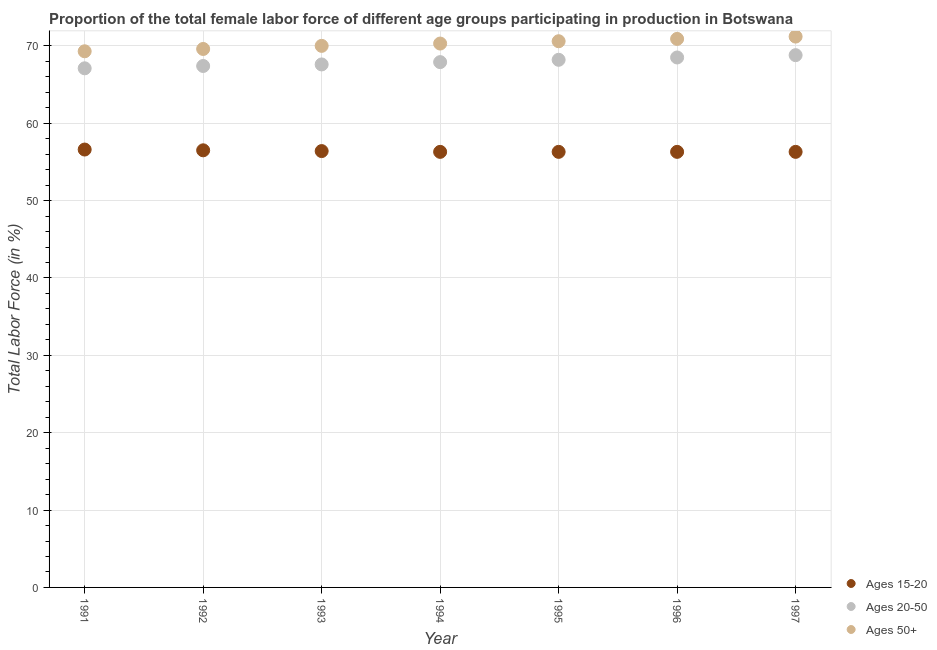Is the number of dotlines equal to the number of legend labels?
Keep it short and to the point. Yes. What is the percentage of female labor force within the age group 15-20 in 1993?
Your answer should be very brief. 56.4. Across all years, what is the maximum percentage of female labor force above age 50?
Offer a terse response. 71.2. Across all years, what is the minimum percentage of female labor force above age 50?
Ensure brevity in your answer.  69.3. In which year was the percentage of female labor force above age 50 minimum?
Keep it short and to the point. 1991. What is the total percentage of female labor force above age 50 in the graph?
Your answer should be compact. 491.9. What is the difference between the percentage of female labor force within the age group 20-50 in 1994 and that in 1997?
Make the answer very short. -0.9. What is the difference between the percentage of female labor force within the age group 15-20 in 1994 and the percentage of female labor force above age 50 in 1993?
Make the answer very short. -13.7. What is the average percentage of female labor force above age 50 per year?
Your response must be concise. 70.27. In the year 1996, what is the difference between the percentage of female labor force within the age group 15-20 and percentage of female labor force within the age group 20-50?
Provide a succinct answer. -12.2. In how many years, is the percentage of female labor force within the age group 20-50 greater than 18 %?
Give a very brief answer. 7. What is the ratio of the percentage of female labor force above age 50 in 1992 to that in 1996?
Your answer should be very brief. 0.98. Is the difference between the percentage of female labor force within the age group 15-20 in 1991 and 1997 greater than the difference between the percentage of female labor force within the age group 20-50 in 1991 and 1997?
Your response must be concise. Yes. What is the difference between the highest and the second highest percentage of female labor force above age 50?
Your response must be concise. 0.3. What is the difference between the highest and the lowest percentage of female labor force within the age group 20-50?
Provide a short and direct response. 1.7. Is the sum of the percentage of female labor force above age 50 in 1992 and 1993 greater than the maximum percentage of female labor force within the age group 15-20 across all years?
Offer a very short reply. Yes. Is it the case that in every year, the sum of the percentage of female labor force within the age group 15-20 and percentage of female labor force within the age group 20-50 is greater than the percentage of female labor force above age 50?
Provide a short and direct response. Yes. Does the percentage of female labor force within the age group 15-20 monotonically increase over the years?
Keep it short and to the point. No. How many years are there in the graph?
Ensure brevity in your answer.  7. Are the values on the major ticks of Y-axis written in scientific E-notation?
Make the answer very short. No. Does the graph contain grids?
Give a very brief answer. Yes. How many legend labels are there?
Offer a very short reply. 3. What is the title of the graph?
Give a very brief answer. Proportion of the total female labor force of different age groups participating in production in Botswana. What is the label or title of the X-axis?
Provide a succinct answer. Year. What is the label or title of the Y-axis?
Provide a short and direct response. Total Labor Force (in %). What is the Total Labor Force (in %) in Ages 15-20 in 1991?
Your answer should be compact. 56.6. What is the Total Labor Force (in %) of Ages 20-50 in 1991?
Keep it short and to the point. 67.1. What is the Total Labor Force (in %) in Ages 50+ in 1991?
Keep it short and to the point. 69.3. What is the Total Labor Force (in %) in Ages 15-20 in 1992?
Keep it short and to the point. 56.5. What is the Total Labor Force (in %) of Ages 20-50 in 1992?
Make the answer very short. 67.4. What is the Total Labor Force (in %) in Ages 50+ in 1992?
Offer a terse response. 69.6. What is the Total Labor Force (in %) in Ages 15-20 in 1993?
Make the answer very short. 56.4. What is the Total Labor Force (in %) in Ages 20-50 in 1993?
Offer a terse response. 67.6. What is the Total Labor Force (in %) in Ages 50+ in 1993?
Offer a very short reply. 70. What is the Total Labor Force (in %) of Ages 15-20 in 1994?
Your answer should be very brief. 56.3. What is the Total Labor Force (in %) in Ages 20-50 in 1994?
Offer a very short reply. 67.9. What is the Total Labor Force (in %) in Ages 50+ in 1994?
Ensure brevity in your answer.  70.3. What is the Total Labor Force (in %) of Ages 15-20 in 1995?
Give a very brief answer. 56.3. What is the Total Labor Force (in %) of Ages 20-50 in 1995?
Offer a very short reply. 68.2. What is the Total Labor Force (in %) in Ages 50+ in 1995?
Offer a very short reply. 70.6. What is the Total Labor Force (in %) in Ages 15-20 in 1996?
Ensure brevity in your answer.  56.3. What is the Total Labor Force (in %) of Ages 20-50 in 1996?
Ensure brevity in your answer.  68.5. What is the Total Labor Force (in %) of Ages 50+ in 1996?
Provide a succinct answer. 70.9. What is the Total Labor Force (in %) of Ages 15-20 in 1997?
Offer a very short reply. 56.3. What is the Total Labor Force (in %) in Ages 20-50 in 1997?
Keep it short and to the point. 68.8. What is the Total Labor Force (in %) of Ages 50+ in 1997?
Give a very brief answer. 71.2. Across all years, what is the maximum Total Labor Force (in %) in Ages 15-20?
Offer a very short reply. 56.6. Across all years, what is the maximum Total Labor Force (in %) of Ages 20-50?
Offer a very short reply. 68.8. Across all years, what is the maximum Total Labor Force (in %) in Ages 50+?
Ensure brevity in your answer.  71.2. Across all years, what is the minimum Total Labor Force (in %) of Ages 15-20?
Provide a short and direct response. 56.3. Across all years, what is the minimum Total Labor Force (in %) in Ages 20-50?
Give a very brief answer. 67.1. Across all years, what is the minimum Total Labor Force (in %) of Ages 50+?
Your response must be concise. 69.3. What is the total Total Labor Force (in %) of Ages 15-20 in the graph?
Ensure brevity in your answer.  394.7. What is the total Total Labor Force (in %) in Ages 20-50 in the graph?
Your response must be concise. 475.5. What is the total Total Labor Force (in %) of Ages 50+ in the graph?
Your answer should be compact. 491.9. What is the difference between the Total Labor Force (in %) in Ages 20-50 in 1991 and that in 1992?
Your answer should be compact. -0.3. What is the difference between the Total Labor Force (in %) of Ages 15-20 in 1991 and that in 1993?
Give a very brief answer. 0.2. What is the difference between the Total Labor Force (in %) of Ages 50+ in 1991 and that in 1993?
Ensure brevity in your answer.  -0.7. What is the difference between the Total Labor Force (in %) in Ages 15-20 in 1991 and that in 1994?
Keep it short and to the point. 0.3. What is the difference between the Total Labor Force (in %) in Ages 50+ in 1991 and that in 1994?
Provide a succinct answer. -1. What is the difference between the Total Labor Force (in %) in Ages 20-50 in 1991 and that in 1995?
Your response must be concise. -1.1. What is the difference between the Total Labor Force (in %) of Ages 50+ in 1991 and that in 1995?
Provide a succinct answer. -1.3. What is the difference between the Total Labor Force (in %) of Ages 50+ in 1991 and that in 1996?
Your response must be concise. -1.6. What is the difference between the Total Labor Force (in %) in Ages 15-20 in 1991 and that in 1997?
Your answer should be very brief. 0.3. What is the difference between the Total Labor Force (in %) in Ages 50+ in 1991 and that in 1997?
Your response must be concise. -1.9. What is the difference between the Total Labor Force (in %) of Ages 15-20 in 1992 and that in 1994?
Keep it short and to the point. 0.2. What is the difference between the Total Labor Force (in %) of Ages 15-20 in 1992 and that in 1995?
Your response must be concise. 0.2. What is the difference between the Total Labor Force (in %) of Ages 50+ in 1992 and that in 1995?
Your answer should be very brief. -1. What is the difference between the Total Labor Force (in %) in Ages 15-20 in 1992 and that in 1996?
Ensure brevity in your answer.  0.2. What is the difference between the Total Labor Force (in %) in Ages 50+ in 1992 and that in 1996?
Keep it short and to the point. -1.3. What is the difference between the Total Labor Force (in %) in Ages 15-20 in 1992 and that in 1997?
Your answer should be very brief. 0.2. What is the difference between the Total Labor Force (in %) in Ages 20-50 in 1992 and that in 1997?
Offer a terse response. -1.4. What is the difference between the Total Labor Force (in %) of Ages 15-20 in 1993 and that in 1997?
Keep it short and to the point. 0.1. What is the difference between the Total Labor Force (in %) in Ages 50+ in 1993 and that in 1997?
Provide a succinct answer. -1.2. What is the difference between the Total Labor Force (in %) in Ages 20-50 in 1994 and that in 1995?
Your answer should be compact. -0.3. What is the difference between the Total Labor Force (in %) in Ages 20-50 in 1994 and that in 1996?
Offer a very short reply. -0.6. What is the difference between the Total Labor Force (in %) of Ages 15-20 in 1994 and that in 1997?
Ensure brevity in your answer.  0. What is the difference between the Total Labor Force (in %) in Ages 20-50 in 1994 and that in 1997?
Provide a succinct answer. -0.9. What is the difference between the Total Labor Force (in %) in Ages 50+ in 1994 and that in 1997?
Offer a terse response. -0.9. What is the difference between the Total Labor Force (in %) in Ages 50+ in 1995 and that in 1996?
Make the answer very short. -0.3. What is the difference between the Total Labor Force (in %) of Ages 20-50 in 1995 and that in 1997?
Provide a succinct answer. -0.6. What is the difference between the Total Labor Force (in %) in Ages 15-20 in 1996 and that in 1997?
Ensure brevity in your answer.  0. What is the difference between the Total Labor Force (in %) in Ages 15-20 in 1991 and the Total Labor Force (in %) in Ages 20-50 in 1992?
Keep it short and to the point. -10.8. What is the difference between the Total Labor Force (in %) in Ages 15-20 in 1991 and the Total Labor Force (in %) in Ages 50+ in 1992?
Keep it short and to the point. -13. What is the difference between the Total Labor Force (in %) in Ages 15-20 in 1991 and the Total Labor Force (in %) in Ages 20-50 in 1993?
Make the answer very short. -11. What is the difference between the Total Labor Force (in %) of Ages 15-20 in 1991 and the Total Labor Force (in %) of Ages 50+ in 1993?
Give a very brief answer. -13.4. What is the difference between the Total Labor Force (in %) of Ages 15-20 in 1991 and the Total Labor Force (in %) of Ages 50+ in 1994?
Keep it short and to the point. -13.7. What is the difference between the Total Labor Force (in %) of Ages 15-20 in 1991 and the Total Labor Force (in %) of Ages 20-50 in 1995?
Offer a very short reply. -11.6. What is the difference between the Total Labor Force (in %) of Ages 15-20 in 1991 and the Total Labor Force (in %) of Ages 20-50 in 1996?
Offer a terse response. -11.9. What is the difference between the Total Labor Force (in %) of Ages 15-20 in 1991 and the Total Labor Force (in %) of Ages 50+ in 1996?
Keep it short and to the point. -14.3. What is the difference between the Total Labor Force (in %) of Ages 15-20 in 1991 and the Total Labor Force (in %) of Ages 50+ in 1997?
Make the answer very short. -14.6. What is the difference between the Total Labor Force (in %) in Ages 20-50 in 1991 and the Total Labor Force (in %) in Ages 50+ in 1997?
Your response must be concise. -4.1. What is the difference between the Total Labor Force (in %) in Ages 15-20 in 1992 and the Total Labor Force (in %) in Ages 20-50 in 1993?
Your answer should be compact. -11.1. What is the difference between the Total Labor Force (in %) of Ages 15-20 in 1992 and the Total Labor Force (in %) of Ages 50+ in 1993?
Give a very brief answer. -13.5. What is the difference between the Total Labor Force (in %) in Ages 15-20 in 1992 and the Total Labor Force (in %) in Ages 50+ in 1995?
Your response must be concise. -14.1. What is the difference between the Total Labor Force (in %) of Ages 15-20 in 1992 and the Total Labor Force (in %) of Ages 50+ in 1996?
Keep it short and to the point. -14.4. What is the difference between the Total Labor Force (in %) in Ages 15-20 in 1992 and the Total Labor Force (in %) in Ages 50+ in 1997?
Offer a terse response. -14.7. What is the difference between the Total Labor Force (in %) in Ages 20-50 in 1992 and the Total Labor Force (in %) in Ages 50+ in 1997?
Your answer should be compact. -3.8. What is the difference between the Total Labor Force (in %) of Ages 20-50 in 1993 and the Total Labor Force (in %) of Ages 50+ in 1994?
Make the answer very short. -2.7. What is the difference between the Total Labor Force (in %) of Ages 15-20 in 1993 and the Total Labor Force (in %) of Ages 20-50 in 1995?
Keep it short and to the point. -11.8. What is the difference between the Total Labor Force (in %) of Ages 15-20 in 1993 and the Total Labor Force (in %) of Ages 50+ in 1995?
Your answer should be compact. -14.2. What is the difference between the Total Labor Force (in %) in Ages 15-20 in 1993 and the Total Labor Force (in %) in Ages 20-50 in 1996?
Give a very brief answer. -12.1. What is the difference between the Total Labor Force (in %) in Ages 15-20 in 1993 and the Total Labor Force (in %) in Ages 50+ in 1996?
Ensure brevity in your answer.  -14.5. What is the difference between the Total Labor Force (in %) in Ages 15-20 in 1993 and the Total Labor Force (in %) in Ages 50+ in 1997?
Ensure brevity in your answer.  -14.8. What is the difference between the Total Labor Force (in %) in Ages 15-20 in 1994 and the Total Labor Force (in %) in Ages 50+ in 1995?
Provide a succinct answer. -14.3. What is the difference between the Total Labor Force (in %) of Ages 15-20 in 1994 and the Total Labor Force (in %) of Ages 50+ in 1996?
Your response must be concise. -14.6. What is the difference between the Total Labor Force (in %) of Ages 15-20 in 1994 and the Total Labor Force (in %) of Ages 20-50 in 1997?
Your answer should be very brief. -12.5. What is the difference between the Total Labor Force (in %) of Ages 15-20 in 1994 and the Total Labor Force (in %) of Ages 50+ in 1997?
Your answer should be very brief. -14.9. What is the difference between the Total Labor Force (in %) of Ages 15-20 in 1995 and the Total Labor Force (in %) of Ages 50+ in 1996?
Give a very brief answer. -14.6. What is the difference between the Total Labor Force (in %) in Ages 15-20 in 1995 and the Total Labor Force (in %) in Ages 20-50 in 1997?
Make the answer very short. -12.5. What is the difference between the Total Labor Force (in %) in Ages 15-20 in 1995 and the Total Labor Force (in %) in Ages 50+ in 1997?
Your answer should be compact. -14.9. What is the difference between the Total Labor Force (in %) in Ages 20-50 in 1995 and the Total Labor Force (in %) in Ages 50+ in 1997?
Your answer should be very brief. -3. What is the difference between the Total Labor Force (in %) in Ages 15-20 in 1996 and the Total Labor Force (in %) in Ages 20-50 in 1997?
Offer a very short reply. -12.5. What is the difference between the Total Labor Force (in %) of Ages 15-20 in 1996 and the Total Labor Force (in %) of Ages 50+ in 1997?
Give a very brief answer. -14.9. What is the difference between the Total Labor Force (in %) in Ages 20-50 in 1996 and the Total Labor Force (in %) in Ages 50+ in 1997?
Offer a terse response. -2.7. What is the average Total Labor Force (in %) of Ages 15-20 per year?
Provide a succinct answer. 56.39. What is the average Total Labor Force (in %) of Ages 20-50 per year?
Your answer should be very brief. 67.93. What is the average Total Labor Force (in %) in Ages 50+ per year?
Your response must be concise. 70.27. In the year 1991, what is the difference between the Total Labor Force (in %) in Ages 15-20 and Total Labor Force (in %) in Ages 50+?
Ensure brevity in your answer.  -12.7. In the year 1991, what is the difference between the Total Labor Force (in %) of Ages 20-50 and Total Labor Force (in %) of Ages 50+?
Offer a terse response. -2.2. In the year 1992, what is the difference between the Total Labor Force (in %) of Ages 15-20 and Total Labor Force (in %) of Ages 20-50?
Provide a short and direct response. -10.9. In the year 1992, what is the difference between the Total Labor Force (in %) of Ages 15-20 and Total Labor Force (in %) of Ages 50+?
Your answer should be compact. -13.1. In the year 1992, what is the difference between the Total Labor Force (in %) in Ages 20-50 and Total Labor Force (in %) in Ages 50+?
Make the answer very short. -2.2. In the year 1994, what is the difference between the Total Labor Force (in %) of Ages 15-20 and Total Labor Force (in %) of Ages 20-50?
Make the answer very short. -11.6. In the year 1994, what is the difference between the Total Labor Force (in %) of Ages 20-50 and Total Labor Force (in %) of Ages 50+?
Your response must be concise. -2.4. In the year 1995, what is the difference between the Total Labor Force (in %) in Ages 15-20 and Total Labor Force (in %) in Ages 20-50?
Make the answer very short. -11.9. In the year 1995, what is the difference between the Total Labor Force (in %) in Ages 15-20 and Total Labor Force (in %) in Ages 50+?
Provide a succinct answer. -14.3. In the year 1995, what is the difference between the Total Labor Force (in %) in Ages 20-50 and Total Labor Force (in %) in Ages 50+?
Ensure brevity in your answer.  -2.4. In the year 1996, what is the difference between the Total Labor Force (in %) of Ages 15-20 and Total Labor Force (in %) of Ages 20-50?
Offer a very short reply. -12.2. In the year 1996, what is the difference between the Total Labor Force (in %) of Ages 15-20 and Total Labor Force (in %) of Ages 50+?
Offer a very short reply. -14.6. In the year 1997, what is the difference between the Total Labor Force (in %) in Ages 15-20 and Total Labor Force (in %) in Ages 50+?
Give a very brief answer. -14.9. What is the ratio of the Total Labor Force (in %) in Ages 15-20 in 1991 to that in 1992?
Give a very brief answer. 1. What is the ratio of the Total Labor Force (in %) of Ages 20-50 in 1991 to that in 1992?
Offer a very short reply. 1. What is the ratio of the Total Labor Force (in %) in Ages 50+ in 1991 to that in 1992?
Provide a succinct answer. 1. What is the ratio of the Total Labor Force (in %) of Ages 15-20 in 1991 to that in 1993?
Offer a very short reply. 1. What is the ratio of the Total Labor Force (in %) in Ages 15-20 in 1991 to that in 1994?
Your answer should be very brief. 1.01. What is the ratio of the Total Labor Force (in %) in Ages 50+ in 1991 to that in 1994?
Your response must be concise. 0.99. What is the ratio of the Total Labor Force (in %) in Ages 15-20 in 1991 to that in 1995?
Offer a very short reply. 1.01. What is the ratio of the Total Labor Force (in %) in Ages 20-50 in 1991 to that in 1995?
Give a very brief answer. 0.98. What is the ratio of the Total Labor Force (in %) in Ages 50+ in 1991 to that in 1995?
Make the answer very short. 0.98. What is the ratio of the Total Labor Force (in %) of Ages 15-20 in 1991 to that in 1996?
Offer a terse response. 1.01. What is the ratio of the Total Labor Force (in %) in Ages 20-50 in 1991 to that in 1996?
Your answer should be very brief. 0.98. What is the ratio of the Total Labor Force (in %) of Ages 50+ in 1991 to that in 1996?
Provide a short and direct response. 0.98. What is the ratio of the Total Labor Force (in %) in Ages 20-50 in 1991 to that in 1997?
Your answer should be very brief. 0.98. What is the ratio of the Total Labor Force (in %) in Ages 50+ in 1991 to that in 1997?
Offer a very short reply. 0.97. What is the ratio of the Total Labor Force (in %) in Ages 15-20 in 1992 to that in 1993?
Give a very brief answer. 1. What is the ratio of the Total Labor Force (in %) in Ages 50+ in 1992 to that in 1993?
Make the answer very short. 0.99. What is the ratio of the Total Labor Force (in %) in Ages 15-20 in 1992 to that in 1994?
Provide a short and direct response. 1. What is the ratio of the Total Labor Force (in %) of Ages 20-50 in 1992 to that in 1994?
Give a very brief answer. 0.99. What is the ratio of the Total Labor Force (in %) of Ages 15-20 in 1992 to that in 1995?
Offer a terse response. 1. What is the ratio of the Total Labor Force (in %) of Ages 20-50 in 1992 to that in 1995?
Give a very brief answer. 0.99. What is the ratio of the Total Labor Force (in %) of Ages 50+ in 1992 to that in 1995?
Your answer should be very brief. 0.99. What is the ratio of the Total Labor Force (in %) in Ages 15-20 in 1992 to that in 1996?
Give a very brief answer. 1. What is the ratio of the Total Labor Force (in %) of Ages 20-50 in 1992 to that in 1996?
Offer a very short reply. 0.98. What is the ratio of the Total Labor Force (in %) of Ages 50+ in 1992 to that in 1996?
Your answer should be very brief. 0.98. What is the ratio of the Total Labor Force (in %) in Ages 20-50 in 1992 to that in 1997?
Your answer should be compact. 0.98. What is the ratio of the Total Labor Force (in %) in Ages 50+ in 1992 to that in 1997?
Provide a succinct answer. 0.98. What is the ratio of the Total Labor Force (in %) in Ages 15-20 in 1993 to that in 1994?
Ensure brevity in your answer.  1. What is the ratio of the Total Labor Force (in %) of Ages 20-50 in 1993 to that in 1994?
Give a very brief answer. 1. What is the ratio of the Total Labor Force (in %) of Ages 15-20 in 1993 to that in 1995?
Give a very brief answer. 1. What is the ratio of the Total Labor Force (in %) of Ages 20-50 in 1993 to that in 1996?
Provide a succinct answer. 0.99. What is the ratio of the Total Labor Force (in %) of Ages 50+ in 1993 to that in 1996?
Keep it short and to the point. 0.99. What is the ratio of the Total Labor Force (in %) in Ages 15-20 in 1993 to that in 1997?
Your response must be concise. 1. What is the ratio of the Total Labor Force (in %) in Ages 20-50 in 1993 to that in 1997?
Your answer should be very brief. 0.98. What is the ratio of the Total Labor Force (in %) in Ages 50+ in 1993 to that in 1997?
Your answer should be very brief. 0.98. What is the ratio of the Total Labor Force (in %) of Ages 15-20 in 1994 to that in 1995?
Your answer should be very brief. 1. What is the ratio of the Total Labor Force (in %) in Ages 20-50 in 1994 to that in 1995?
Provide a short and direct response. 1. What is the ratio of the Total Labor Force (in %) of Ages 50+ in 1994 to that in 1995?
Your answer should be compact. 1. What is the ratio of the Total Labor Force (in %) of Ages 50+ in 1994 to that in 1996?
Keep it short and to the point. 0.99. What is the ratio of the Total Labor Force (in %) in Ages 15-20 in 1994 to that in 1997?
Keep it short and to the point. 1. What is the ratio of the Total Labor Force (in %) in Ages 20-50 in 1994 to that in 1997?
Your answer should be very brief. 0.99. What is the ratio of the Total Labor Force (in %) of Ages 50+ in 1994 to that in 1997?
Offer a very short reply. 0.99. What is the ratio of the Total Labor Force (in %) in Ages 20-50 in 1995 to that in 1997?
Offer a terse response. 0.99. What is the ratio of the Total Labor Force (in %) in Ages 50+ in 1996 to that in 1997?
Ensure brevity in your answer.  1. What is the difference between the highest and the second highest Total Labor Force (in %) of Ages 15-20?
Offer a terse response. 0.1. What is the difference between the highest and the second highest Total Labor Force (in %) of Ages 20-50?
Your answer should be very brief. 0.3. What is the difference between the highest and the second highest Total Labor Force (in %) of Ages 50+?
Ensure brevity in your answer.  0.3. What is the difference between the highest and the lowest Total Labor Force (in %) of Ages 20-50?
Your answer should be compact. 1.7. What is the difference between the highest and the lowest Total Labor Force (in %) of Ages 50+?
Keep it short and to the point. 1.9. 